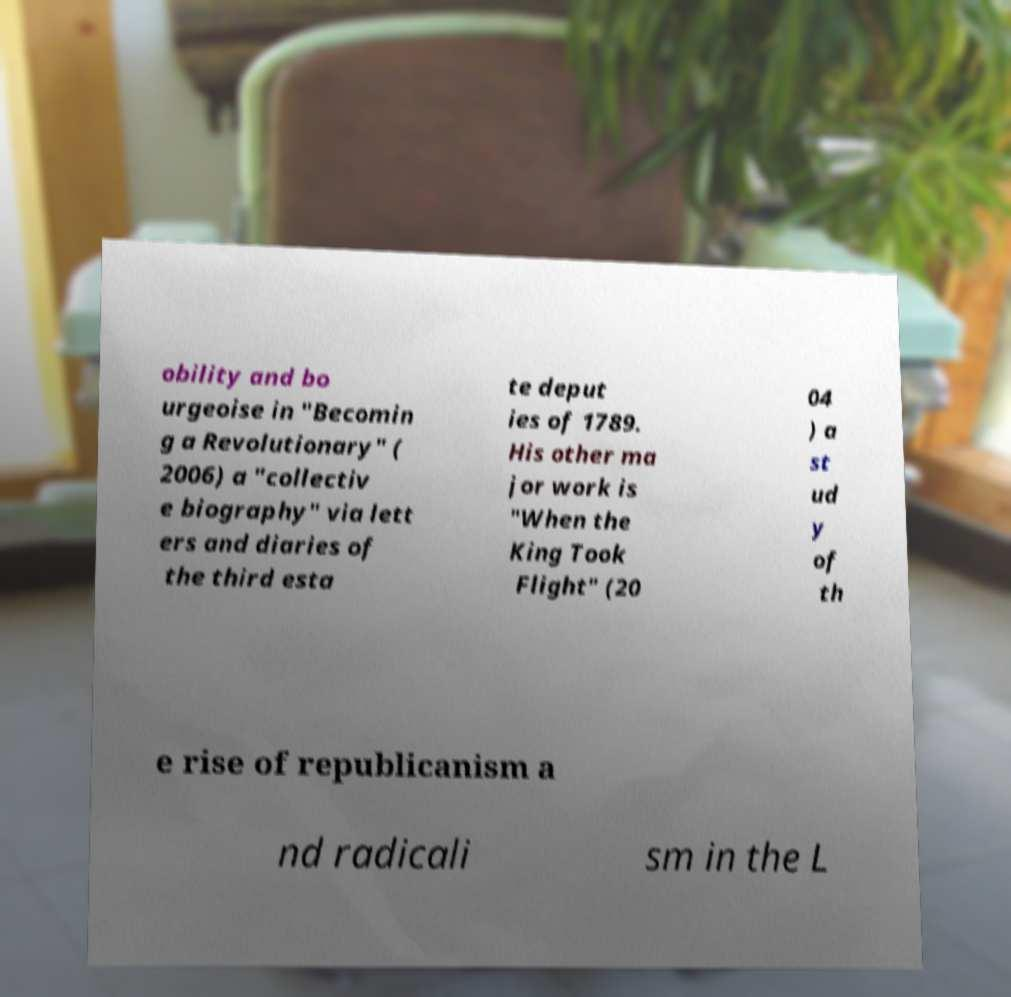There's text embedded in this image that I need extracted. Can you transcribe it verbatim? obility and bo urgeoise in "Becomin g a Revolutionary" ( 2006) a "collectiv e biography" via lett ers and diaries of the third esta te deput ies of 1789. His other ma jor work is "When the King Took Flight" (20 04 ) a st ud y of th e rise of republicanism a nd radicali sm in the L 